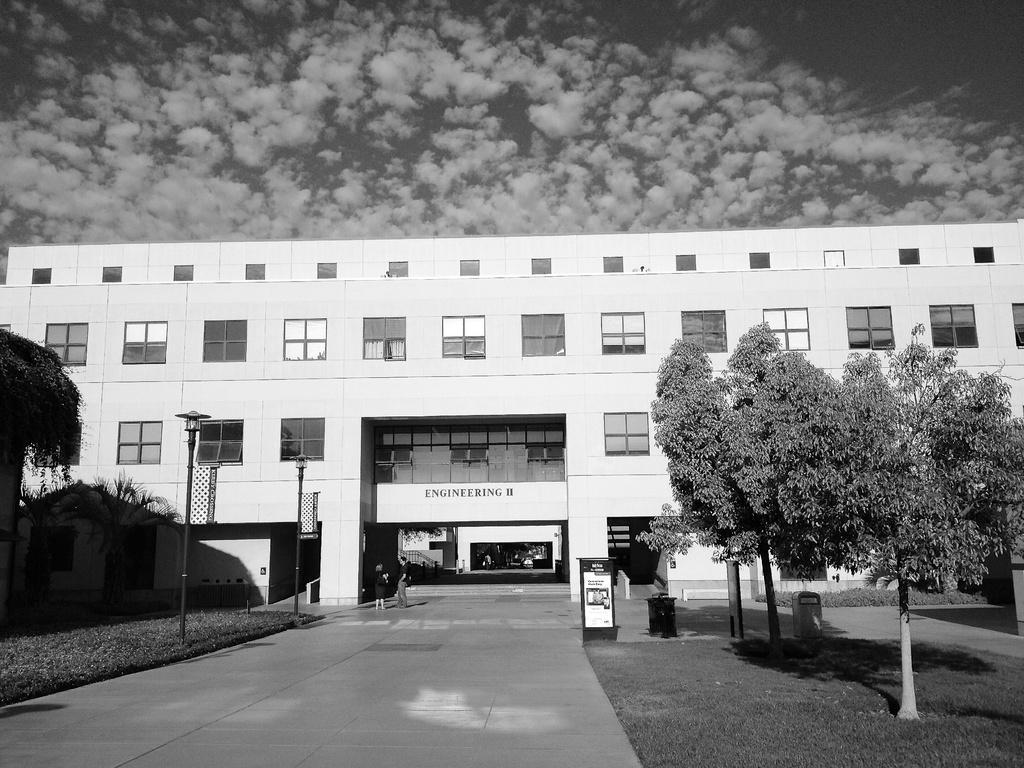Could you give a brief overview of what you see in this image? In the foreground of this image, there is a pavement. On the right, there is grass, few trees and few objects. On the left, there is grass, trees and pole. In the background, there is a building. On the top, there is the sky and the cloud. 